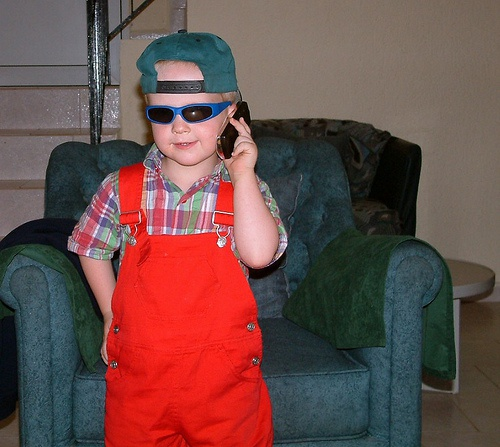Describe the objects in this image and their specific colors. I can see chair in gray, black, blue, and darkblue tones, couch in gray, black, blue, and darkblue tones, people in gray, red, lightpink, brown, and teal tones, and cell phone in gray, black, lightpink, brown, and maroon tones in this image. 